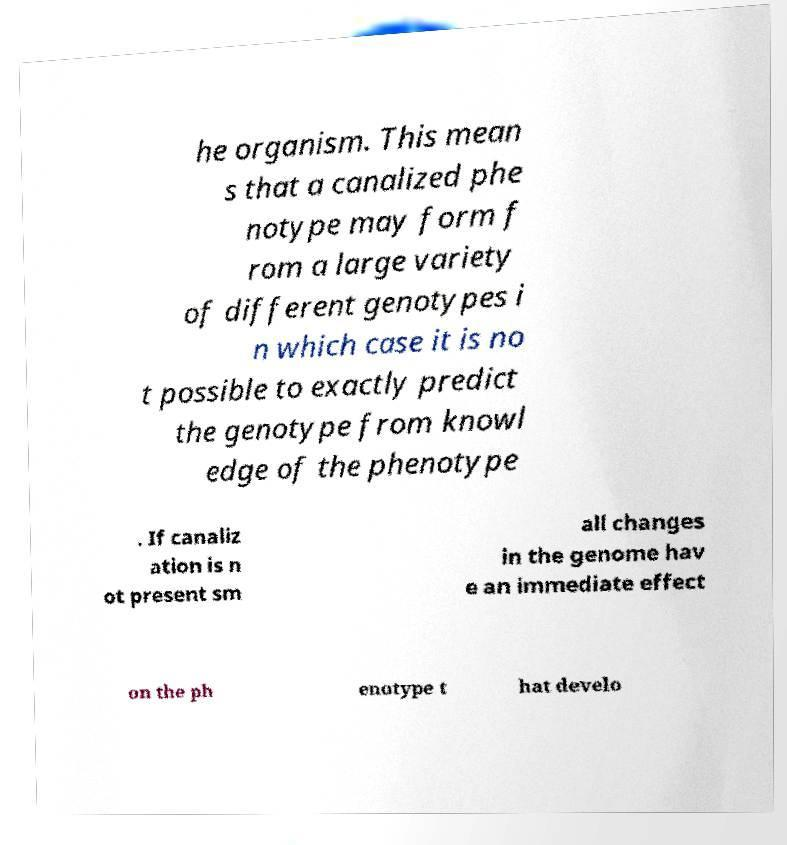Please read and relay the text visible in this image. What does it say? he organism. This mean s that a canalized phe notype may form f rom a large variety of different genotypes i n which case it is no t possible to exactly predict the genotype from knowl edge of the phenotype . If canaliz ation is n ot present sm all changes in the genome hav e an immediate effect on the ph enotype t hat develo 